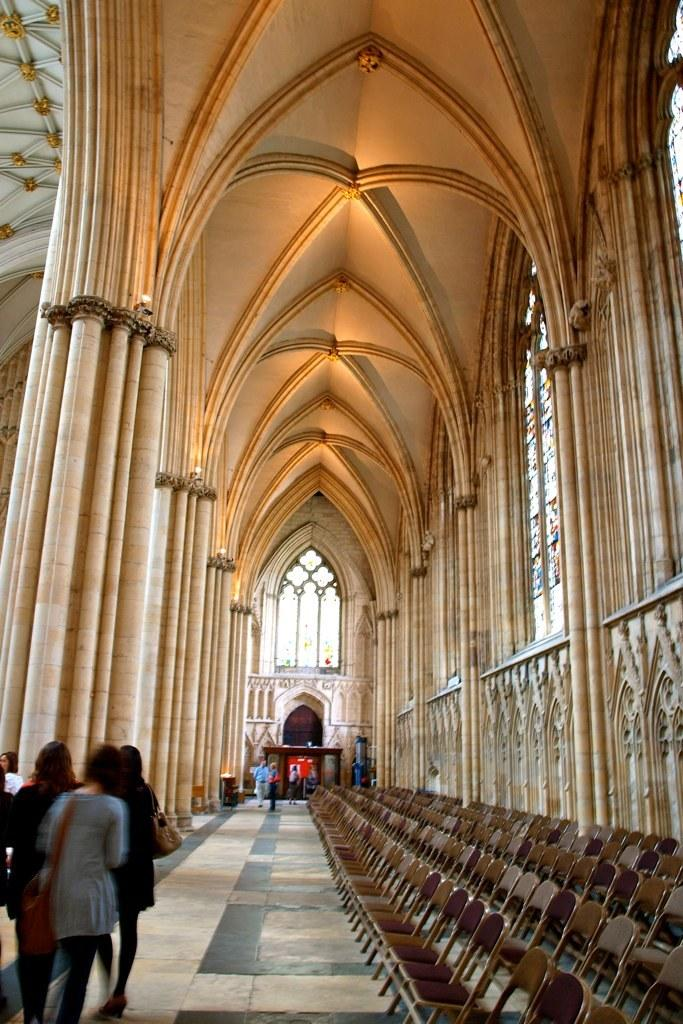What type of furniture can be seen in the image? There are chairs in the image. What type of structure is visible in the image? There is a building in the image. What type of decorative glass can be seen in the image? There are stained glasses in the image. What are the persons in the image doing? There are persons walking on the floor in the image. What type of line can be seen on the stained glass in the image? There is no line mentioned or visible on the stained glass in the image. Is there a veil covering the building in the image? There is no mention or indication of a veil covering the building in the image. 